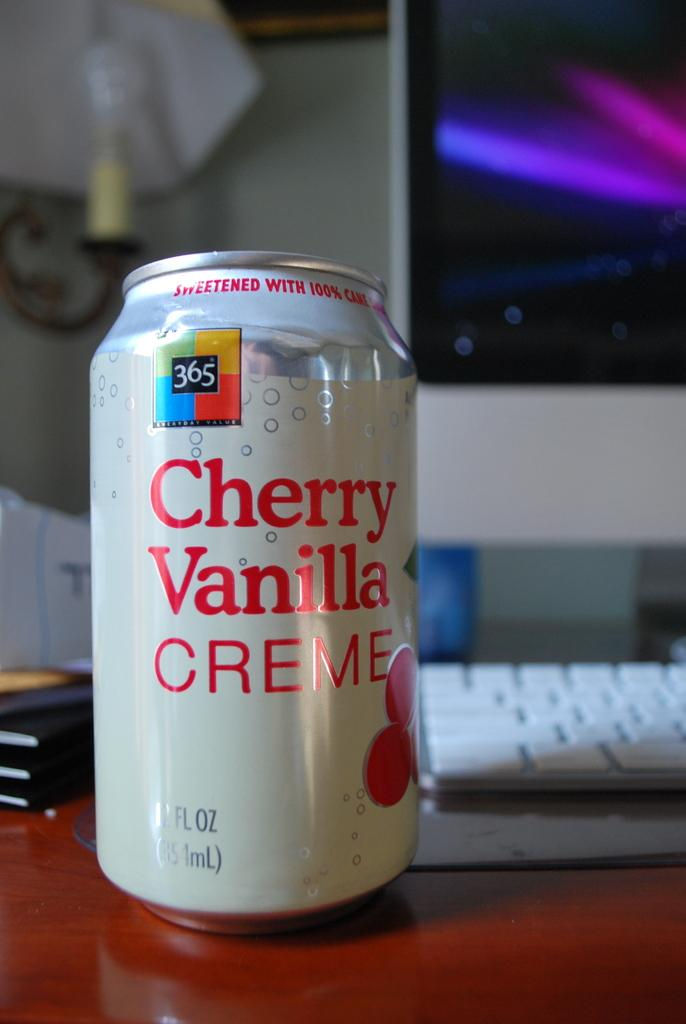Provide a one-sentence caption for the provided image. A can of cherry vanilla creme soda sits on a desk next to a computer. 